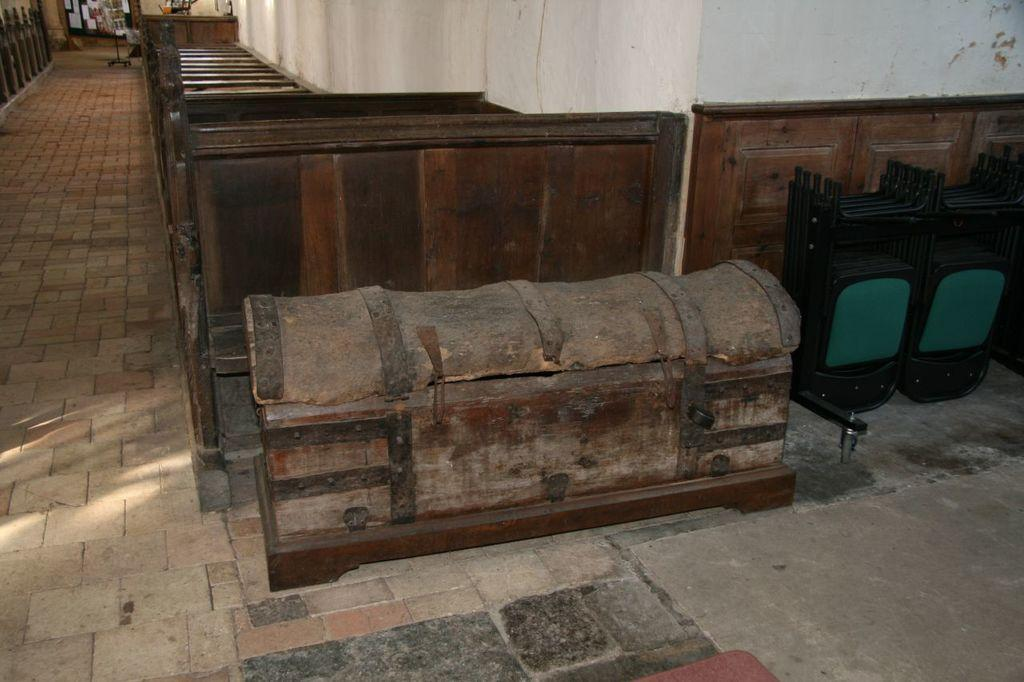What type of surface is visible in the image? There is a floor visible in the image. What else can be seen in the image besides the floor? There is a wall visible in the image. What object can be seen in the image? There is a box in the image. What material are some of the objects made of in the image? There are wooden objects in the image. Can you describe the unspecified objects in the image? There are some unspecified objects in the image. How many stamps can be seen on the wall in the image? There are no stamps visible on the wall in the image. Can you tell me how many men are present in the image? There is no reference to a man or any people in the image. What type of hall is depicted in the image? There is no hall depicted in the image; it only shows a floor, a wall, a box, and some wooden objects. 